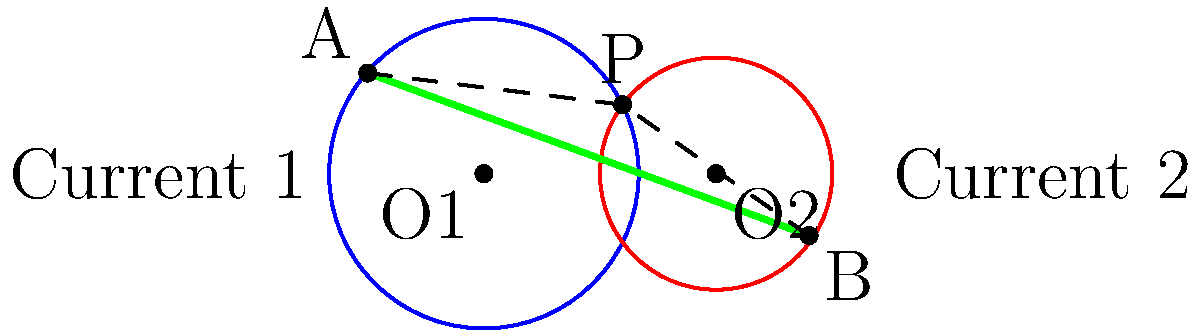In an open water swim race, you encounter two circular current patterns as shown in the diagram. Current 1 (blue) has a radius of 2 units, and Current 2 (red) has a radius of 1.5 units. Their centers are 3 units apart. You need to swim from point A to point B. What is the optimal path to minimize the effects of the currents, and how much shorter is this path compared to swimming directly from A to B? To find the optimal path and calculate the difference in distance:

1) The optimal path to minimize current effects is to swim along the tangent lines of both circles, passing through their intersection point P.

2) To calculate the length of the optimal path:
   a) Find the coordinates of point P using the equation of the two circles:
      $$(x)^2 + y^2 = 4$$ and $$(x-3)^2 + y^2 = 2.25$$
   b) Solving these equations, we get P ≈ (1.2, 1.6)

3) Calculate the length of A-P-B:
   a) Length AP = $\sqrt{(1.2 - (-1.5))^2 + (1.6 - 1.3)^2}$ ≈ 2.72
   b) Length PB = $\sqrt{(4.2 - 1.2)^2 + (-0.8 - 1.6)^2}$ ≈ 3.76
   c) Total optimal path length = 2.72 + 3.76 = 6.48 units

4) Calculate the direct path length A-B:
   $\sqrt{(4.2 - (-1.5))^2 + (-0.8 - 1.3)^2}$ ≈ 6.54 units

5) Difference in length:
   6.54 - 6.48 = 0.06 units

The optimal path is approximately 0.06 units shorter than the direct path.
Answer: Swim through point P; 0.06 units shorter 